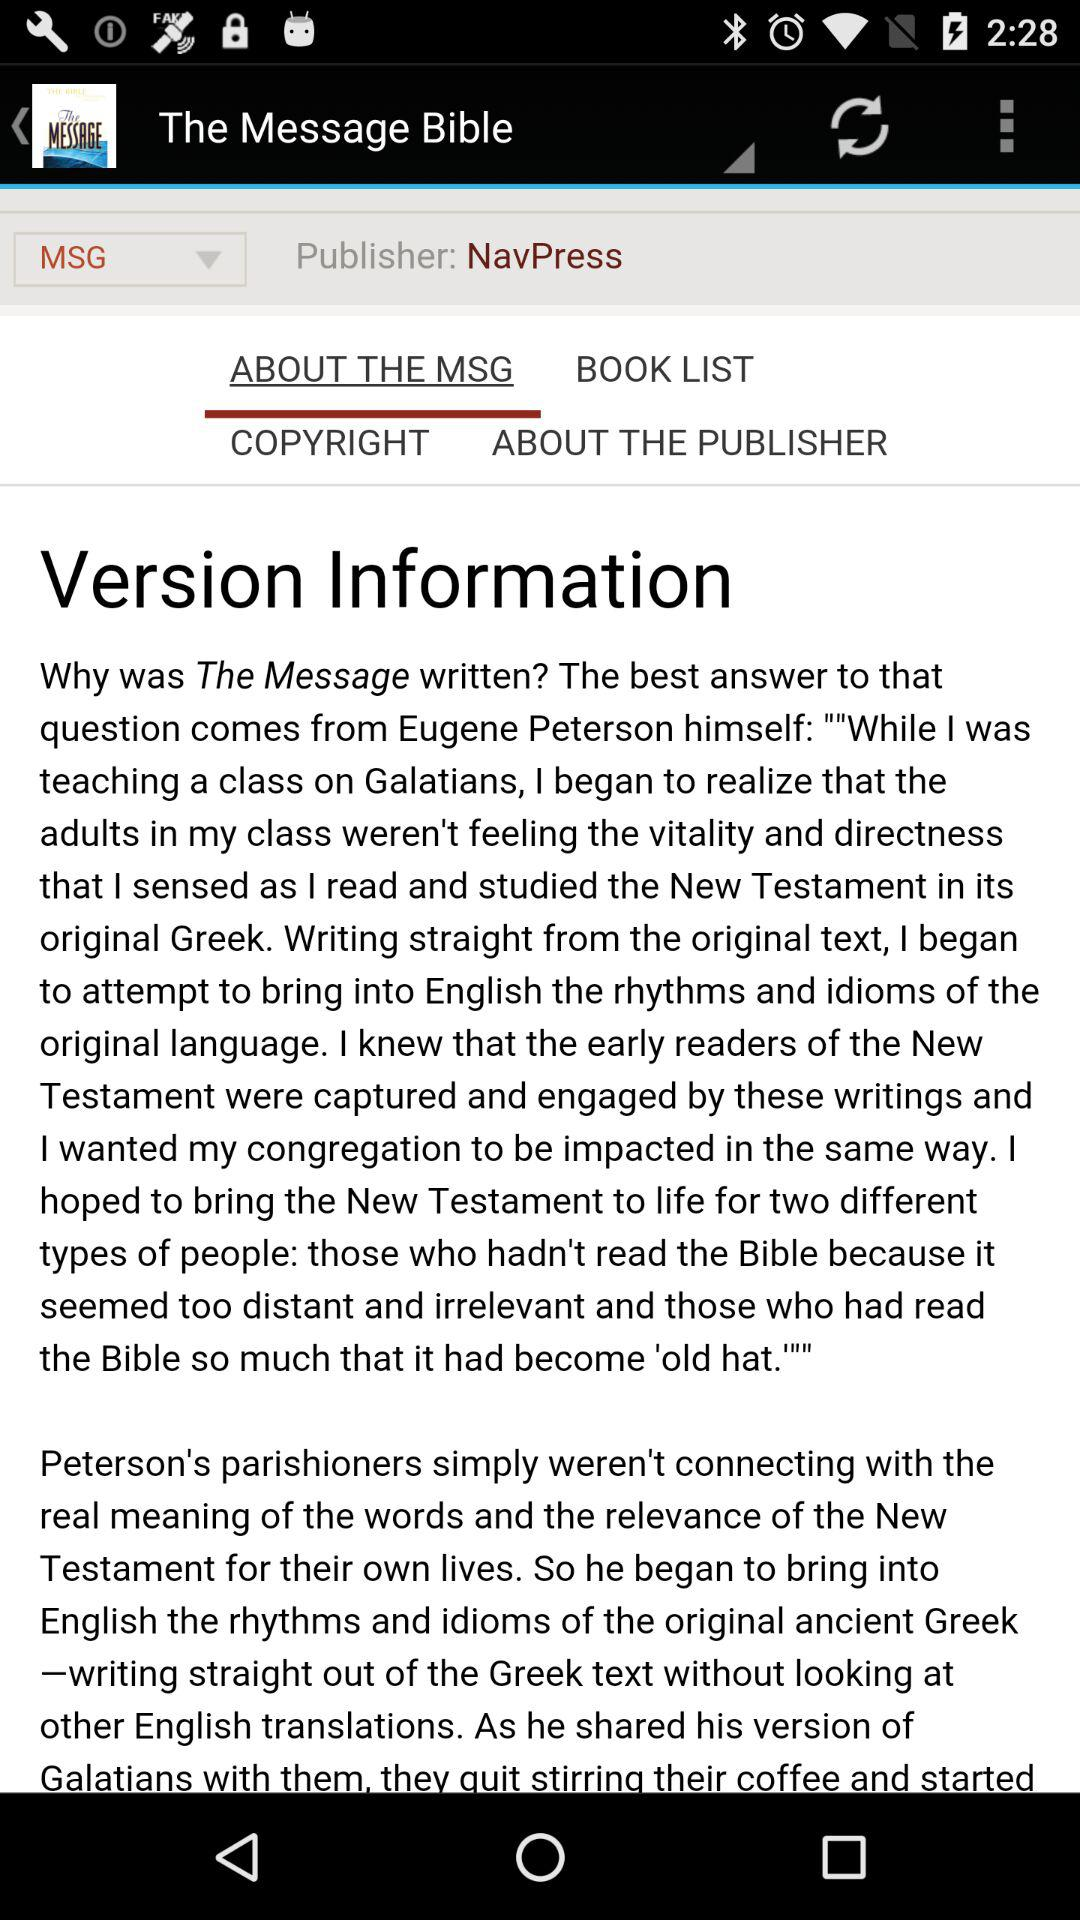Who is the publisher? The publisher is "NavPress". 